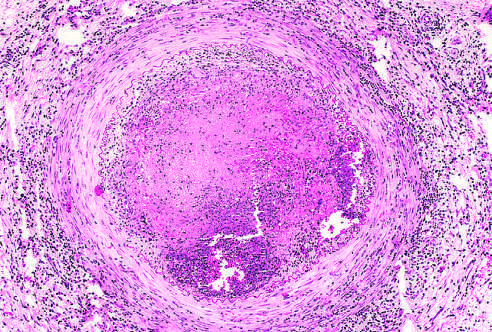what is the lumen occluded by, containing a sterile abscess?
Answer the question using a single word or phrase. Thrombus 